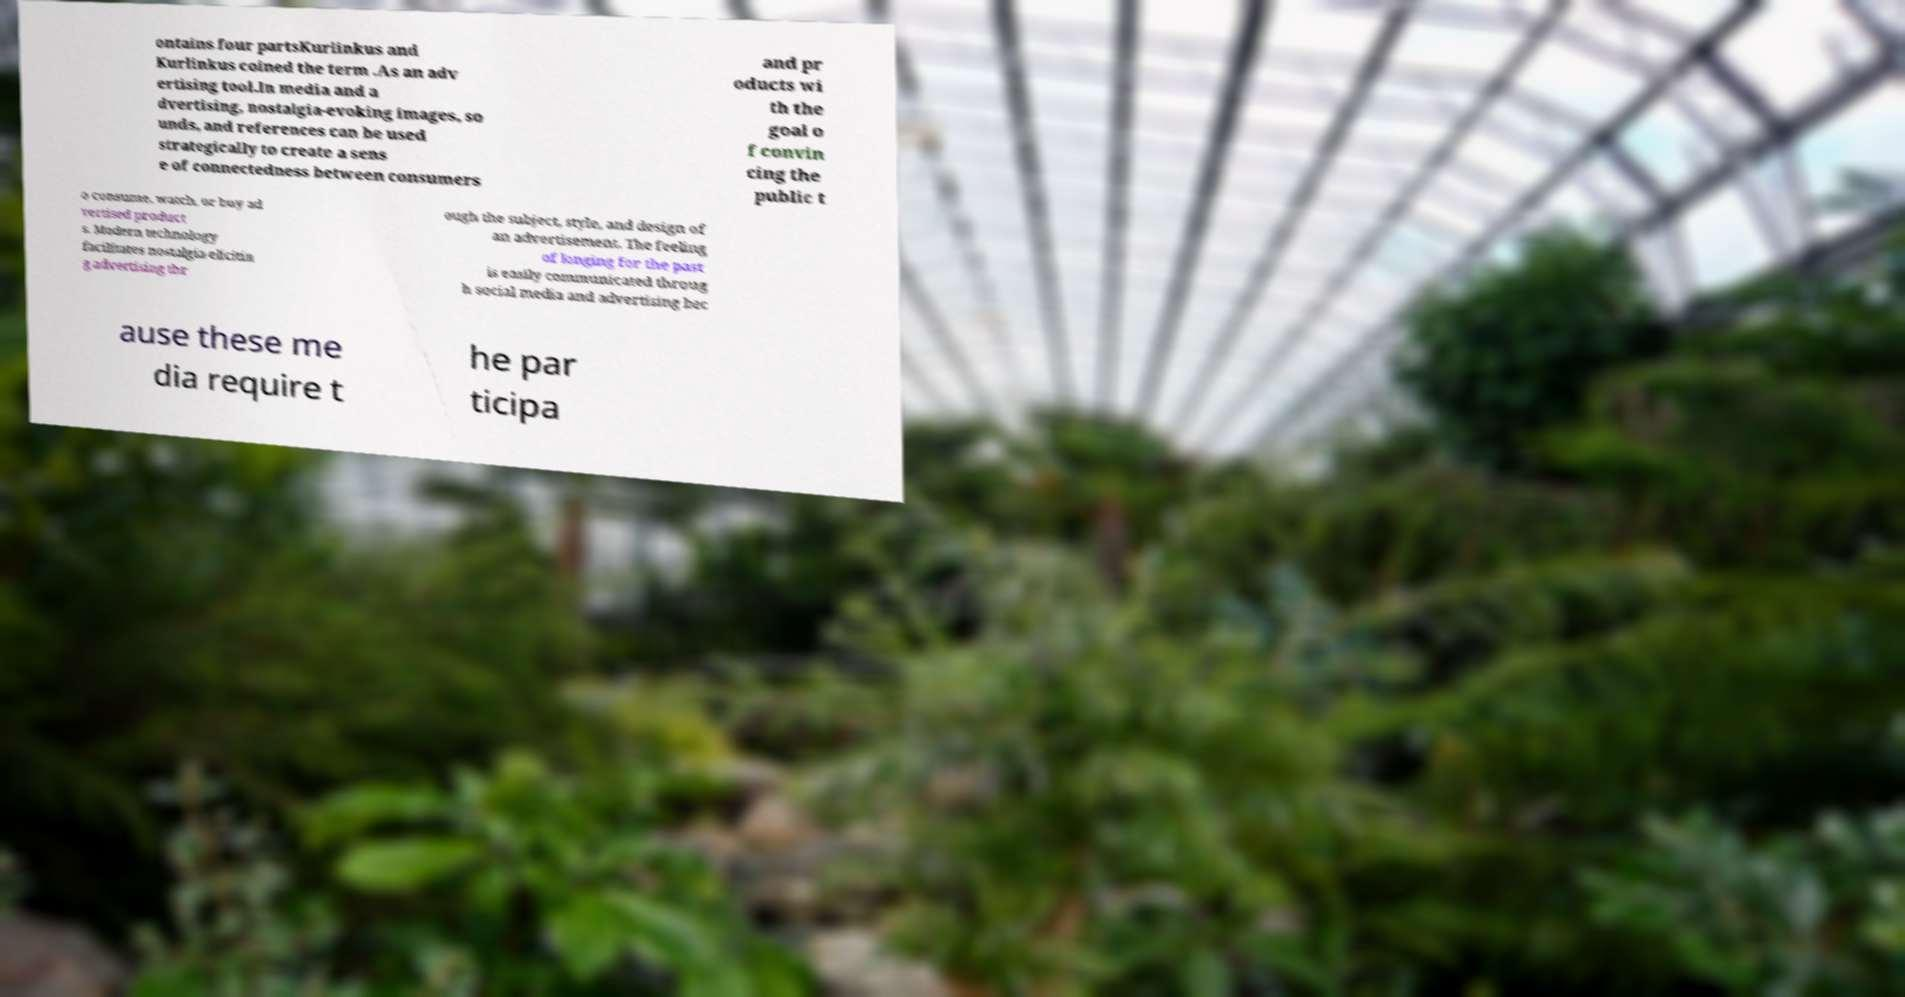Please read and relay the text visible in this image. What does it say? ontains four partsKurlinkus and Kurlinkus coined the term .As an adv ertising tool.In media and a dvertising, nostalgia-evoking images, so unds, and references can be used strategically to create a sens e of connectedness between consumers and pr oducts wi th the goal o f convin cing the public t o consume, watch, or buy ad vertised product s. Modern technology facilitates nostalgia-elicitin g advertising thr ough the subject, style, and design of an advertisement. The feeling of longing for the past is easily communicated throug h social media and advertising bec ause these me dia require t he par ticipa 